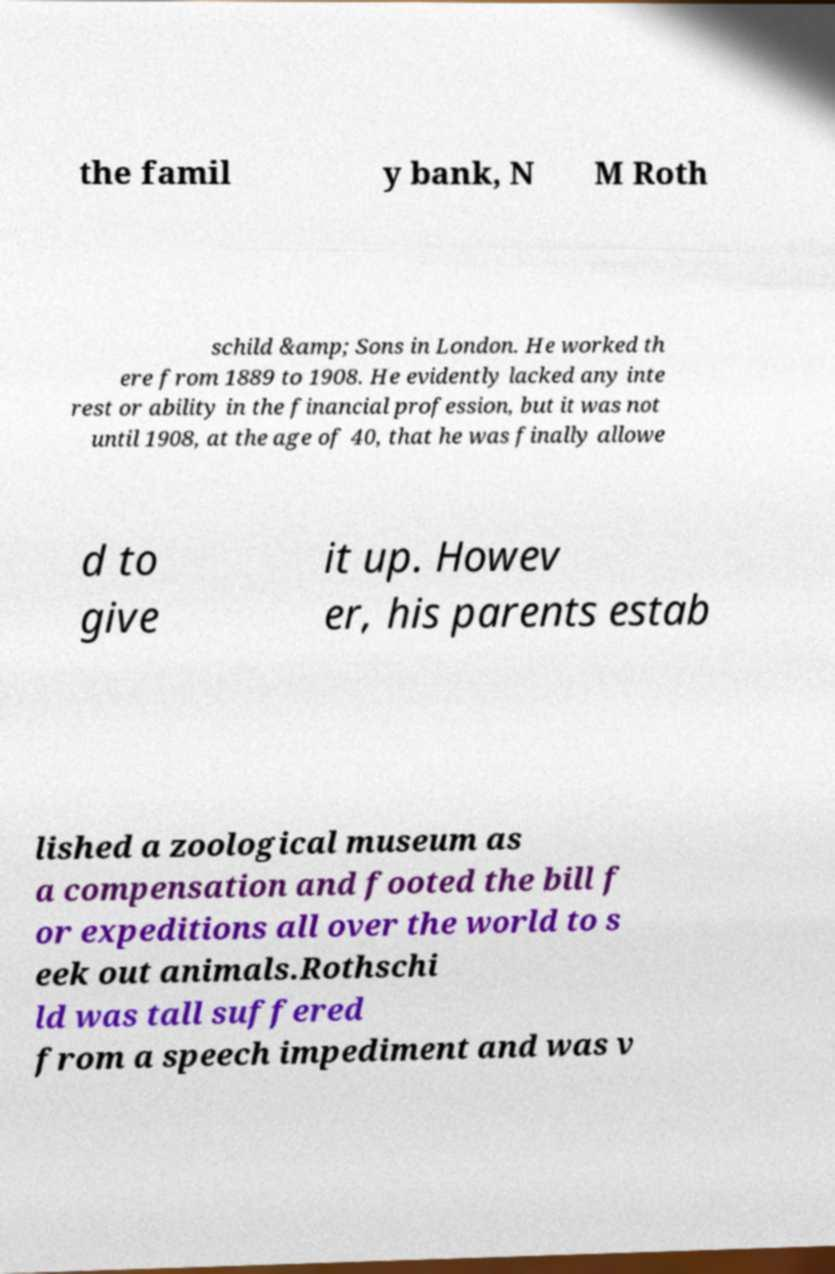Could you extract and type out the text from this image? the famil y bank, N M Roth schild &amp; Sons in London. He worked th ere from 1889 to 1908. He evidently lacked any inte rest or ability in the financial profession, but it was not until 1908, at the age of 40, that he was finally allowe d to give it up. Howev er, his parents estab lished a zoological museum as a compensation and footed the bill f or expeditions all over the world to s eek out animals.Rothschi ld was tall suffered from a speech impediment and was v 